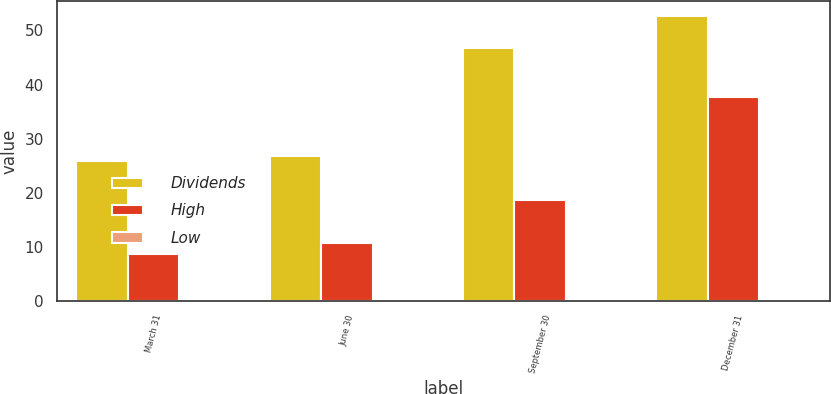<chart> <loc_0><loc_0><loc_500><loc_500><stacked_bar_chart><ecel><fcel>March 31<fcel>June 30<fcel>September 30<fcel>December 31<nl><fcel>Dividends<fcel>25.83<fcel>26.7<fcel>46.81<fcel>52.74<nl><fcel>High<fcel>8.69<fcel>10.68<fcel>18.66<fcel>37.72<nl><fcel>Low<fcel>0.38<fcel>0.1<fcel>0.1<fcel>0.1<nl></chart> 